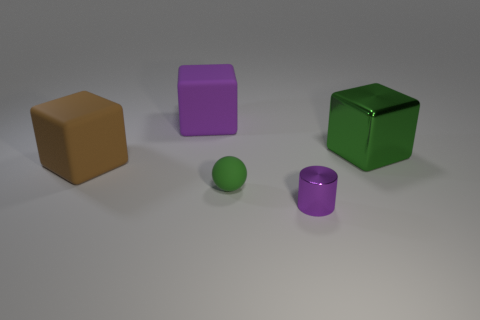What kind of materials do the objects appear to be made of? From the image, the objects seem to have a matte finish, suggesting they could be made of a plastic or rubber-like material. They exhibit soft shadows and even lighting, which does not give away a reflective property that would indicate a metallic or glass material. 